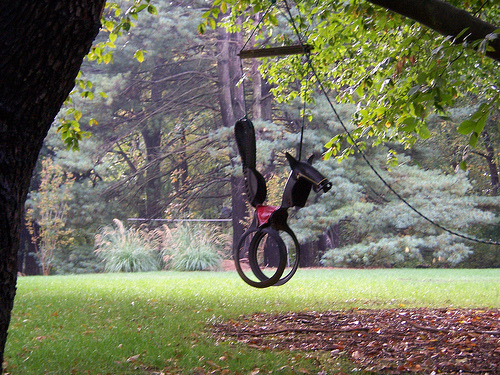<image>
Is the ring behind the other ring? Yes. From this viewpoint, the ring is positioned behind the other ring, with the other ring partially or fully occluding the ring. 